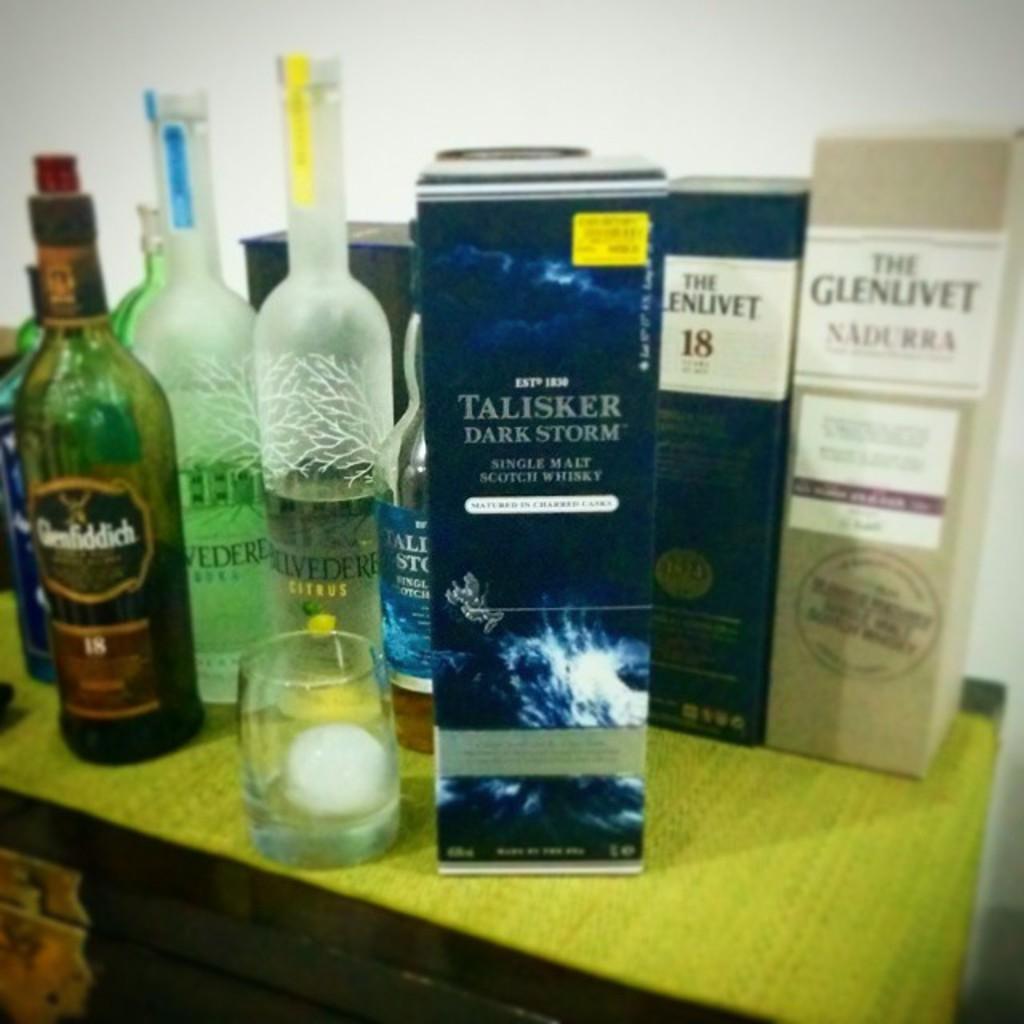How would you summarize this image in a sentence or two? In this picture there are few wine bottles on table. There are pack boxes with bottles beside them. There is a glass in front of the bottles. They are placed on table beside a wall painted in white. 